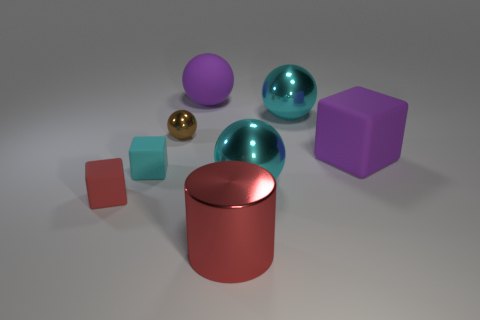Add 1 cyan objects. How many objects exist? 9 Subtract all cylinders. How many objects are left? 7 Add 3 matte blocks. How many matte blocks are left? 6 Add 5 cyan matte objects. How many cyan matte objects exist? 6 Subtract 1 purple balls. How many objects are left? 7 Subtract all brown spheres. Subtract all small cyan rubber cubes. How many objects are left? 6 